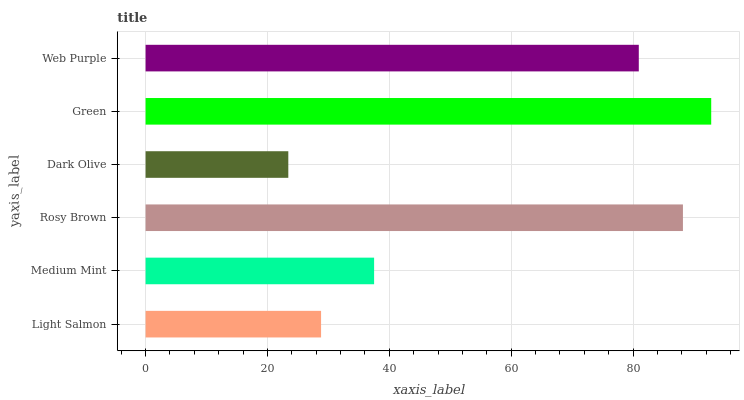Is Dark Olive the minimum?
Answer yes or no. Yes. Is Green the maximum?
Answer yes or no. Yes. Is Medium Mint the minimum?
Answer yes or no. No. Is Medium Mint the maximum?
Answer yes or no. No. Is Medium Mint greater than Light Salmon?
Answer yes or no. Yes. Is Light Salmon less than Medium Mint?
Answer yes or no. Yes. Is Light Salmon greater than Medium Mint?
Answer yes or no. No. Is Medium Mint less than Light Salmon?
Answer yes or no. No. Is Web Purple the high median?
Answer yes or no. Yes. Is Medium Mint the low median?
Answer yes or no. Yes. Is Green the high median?
Answer yes or no. No. Is Web Purple the low median?
Answer yes or no. No. 